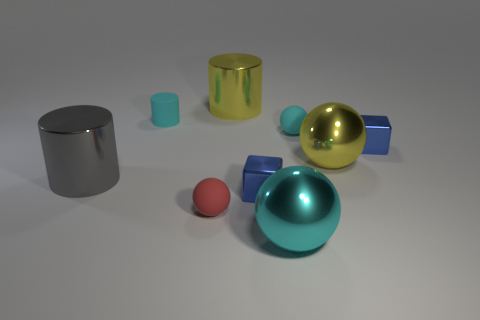Subtract all gray metallic cylinders. How many cylinders are left? 2 Subtract all gray cylinders. How many cylinders are left? 2 Subtract all balls. How many objects are left? 5 Subtract 2 blocks. How many blocks are left? 0 Subtract all purple cylinders. Subtract all yellow spheres. How many cylinders are left? 3 Subtract all cyan cylinders. How many red spheres are left? 1 Subtract all small blue metal things. Subtract all small matte balls. How many objects are left? 5 Add 4 red matte spheres. How many red matte spheres are left? 5 Add 7 large yellow things. How many large yellow things exist? 9 Subtract 1 cyan spheres. How many objects are left? 8 